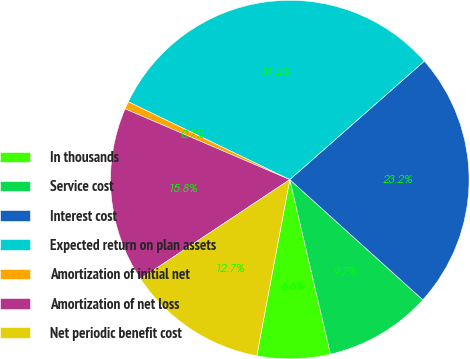Convert chart. <chart><loc_0><loc_0><loc_500><loc_500><pie_chart><fcel>In thousands<fcel>Service cost<fcel>Interest cost<fcel>Expected return on plan assets<fcel>Amortization of initial net<fcel>Amortization of net loss<fcel>Net periodic benefit cost<nl><fcel>6.59%<fcel>9.66%<fcel>23.19%<fcel>31.36%<fcel>0.69%<fcel>15.79%<fcel>12.72%<nl></chart> 